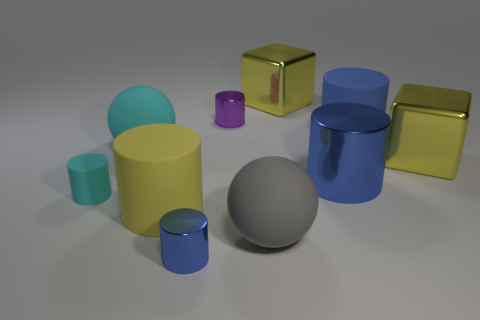Subtract all red balls. How many blue cylinders are left? 3 Subtract all cyan matte cylinders. How many cylinders are left? 5 Subtract 3 cylinders. How many cylinders are left? 3 Subtract all cyan cylinders. How many cylinders are left? 5 Subtract all cyan cylinders. Subtract all yellow cubes. How many cylinders are left? 5 Subtract all blocks. How many objects are left? 8 Add 3 yellow matte objects. How many yellow matte objects are left? 4 Add 6 tiny blue cubes. How many tiny blue cubes exist? 6 Subtract 0 brown blocks. How many objects are left? 10 Subtract all large gray balls. Subtract all big gray balls. How many objects are left? 8 